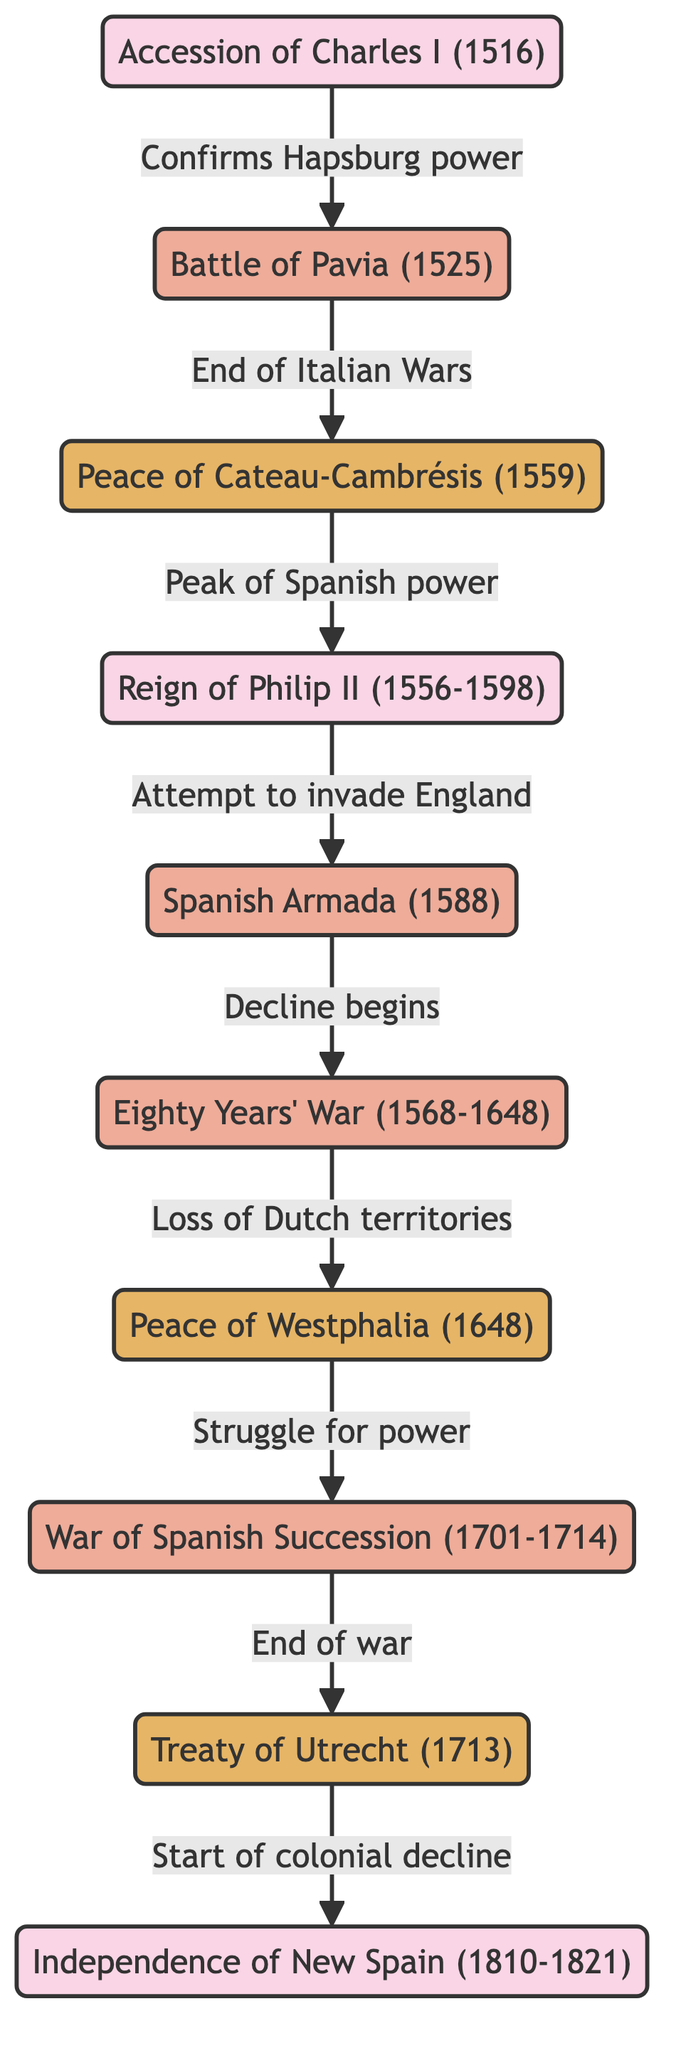What is the first event depicted in this diagram? The first event in the diagram is the Accession of Charles I (1516), as it is the starting node that no other nodes originate from.
Answer: Accession of Charles I (1516) How many battles are represented in the diagram? To find the number of battles, one must count the nodes classified as battles: Battle of Pavia, Spanish Armada, Eighty Years' War, and War of Spanish Succession. This totals to four battle nodes.
Answer: 4 What event marks the end of the Italian Wars? The edge leading from the Battle of Pavia to the Peace of Cateau-Cambrésis is labeled "End of Italian Wars," indicating that the Peace of Cateau-Cambrésis is the event marking this conclusion.
Answer: Peace of Cateau-Cambrésis (1559) What is the relationship between the Peace of Westphalia and the War of Spanish Succession? The diagram shows a directed edge from the Peace of Westphalia to the War of Spanish Succession, labeled "Struggle for power," indicating that the War of Spanish Succession follows this treaty in the context of power struggles.
Answer: Struggle for power What marks the beginning of the colonial decline for Spain? There is a directed edge from the Treaty of Utrecht to New Spain Independence labeled "Start of colonial decline," indicating that the treaty marks the beginning of this decline.
Answer: Start of colonial decline 